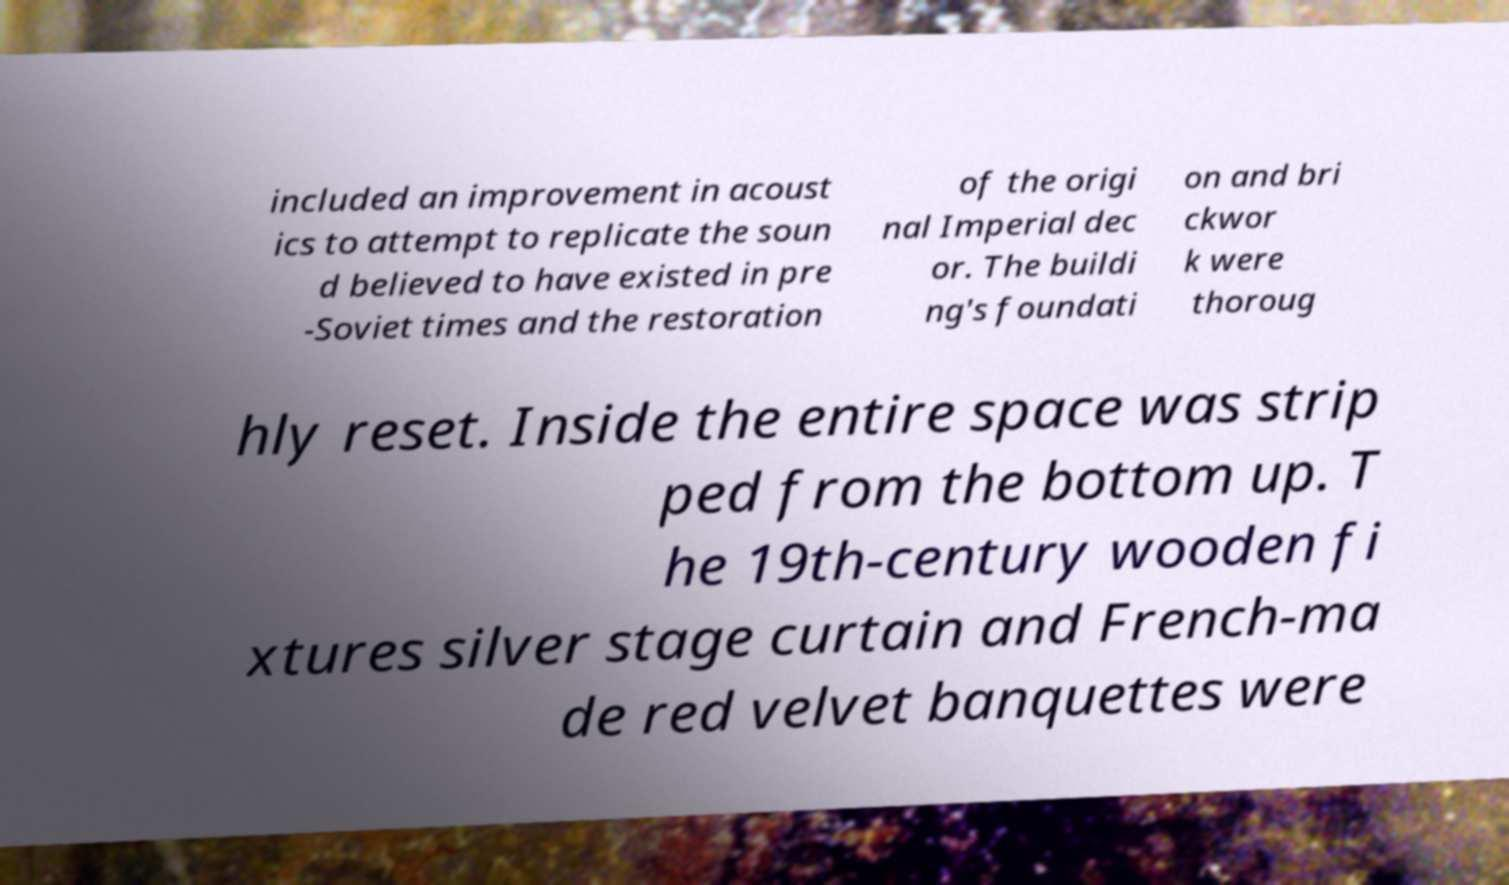Please read and relay the text visible in this image. What does it say? included an improvement in acoust ics to attempt to replicate the soun d believed to have existed in pre -Soviet times and the restoration of the origi nal Imperial dec or. The buildi ng's foundati on and bri ckwor k were thoroug hly reset. Inside the entire space was strip ped from the bottom up. T he 19th-century wooden fi xtures silver stage curtain and French-ma de red velvet banquettes were 